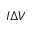<formula> <loc_0><loc_0><loc_500><loc_500>I \Delta V</formula> 